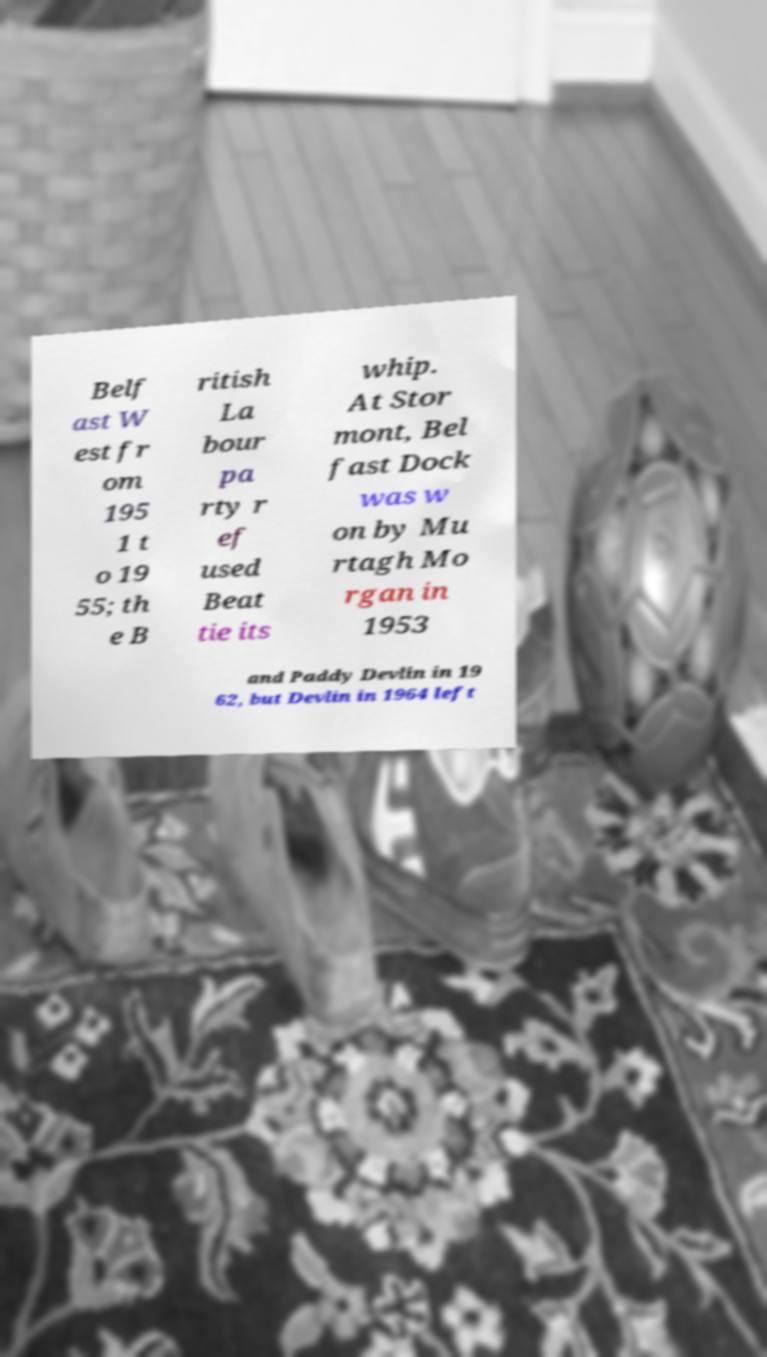Please identify and transcribe the text found in this image. Belf ast W est fr om 195 1 t o 19 55; th e B ritish La bour pa rty r ef used Beat tie its whip. At Stor mont, Bel fast Dock was w on by Mu rtagh Mo rgan in 1953 and Paddy Devlin in 19 62, but Devlin in 1964 left 